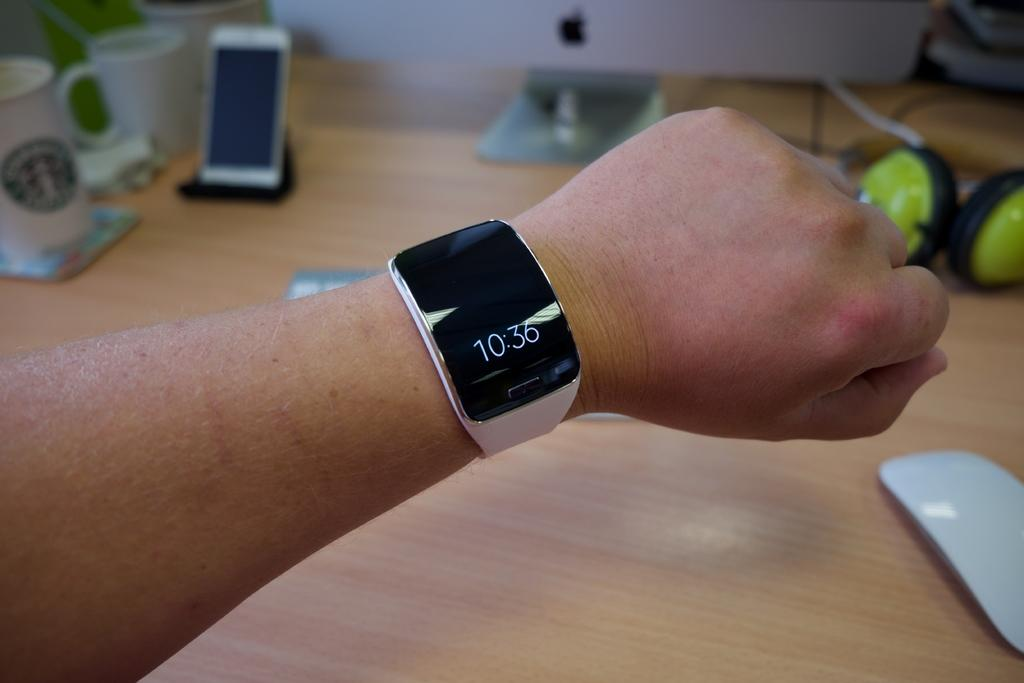<image>
Give a short and clear explanation of the subsequent image. A person is wearing a watch that reads 10:36. 